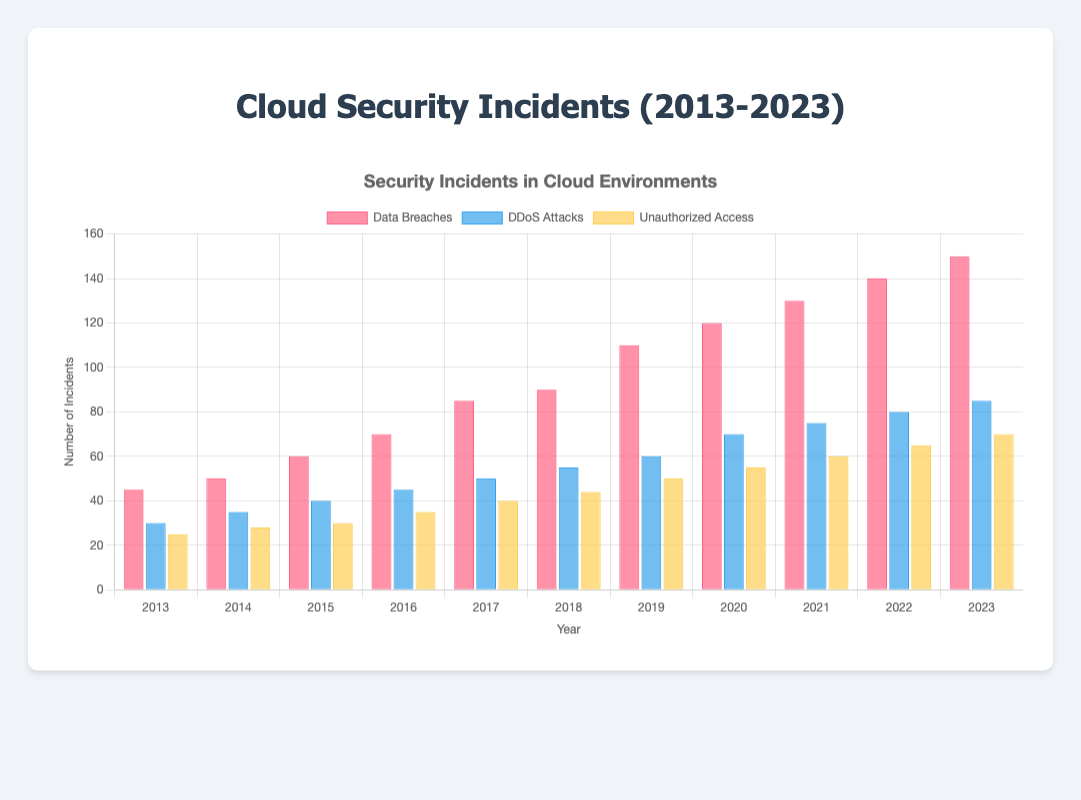What year had the highest number of data breaches? To determine the year with the highest number of data breaches, locate the tallest red bar in the "Data Breaches" group on the chart. The tallest bar corresponds to the year 2023 with 150 incidents.
Answer: 2023 Compare the number of DDoS attacks in 2015 to unauthorized access incidents in 2015. Which was higher? Find the blue and yellow bars for 2015. The blue bar for DDoS attacks indicates 40 incidents, and the yellow bar for unauthorized access shows 30 incidents. Compare the two values to see which is greater.
Answer: DDoS attacks In which year did the number of data breaches surpass 100 for the first time? Look for the first red bar that exceeds the height corresponding to 100 incidents. This happens in the year 2019 with 110 incidents.
Answer: 2019 What is the average number of unauthorized access incidents from 2013 to 2015? Sum the yellow bars for unauthorized access from 2013, 2014, and 2015 (25, 28, and 30). Then divide by the number of years (3): (25 + 28 + 30) / 3 = 83 / 3 = 27.67.
Answer: 27.67 How many more data breaches occurred in 2022 compared to 2017? Subtract the number of data breaches in 2017 (85) from the number in 2022 (140): 140 - 85 = 55.
Answer: 55 Compare the highest number of DDoS attacks to the highest number of unauthorized access incidents. Which is greater? The highest number of DDoS attacks (blue) is 85 in 2023. The highest number of unauthorized access incidents (yellow) is 70 in 2023. Compare 85 and 70 to determine which is greater.
Answer: DDoS attacks What year had the lowest number of security incidents overall when combining all types? Sum the bars for each year and compare. In 2013, the total is 45 (data breaches) + 30 (DDoS attacks) + 25 (unauthorized access) = 100. This is the smallest total across all years.
Answer: 2013 How did the frequency of DDoS attacks change from 2016 to 2020? Look at the blue bars from 2016 to 2020: 45, 50, 55, 60, 70. Note the increasing trend each year.
Answer: Increased Which year had equal numbers of unauthorized access incidents and data breaches? There is no year where the yellow (unauthorized access) and red (data breaches) bars are equal upon inspection.
Answer: None 